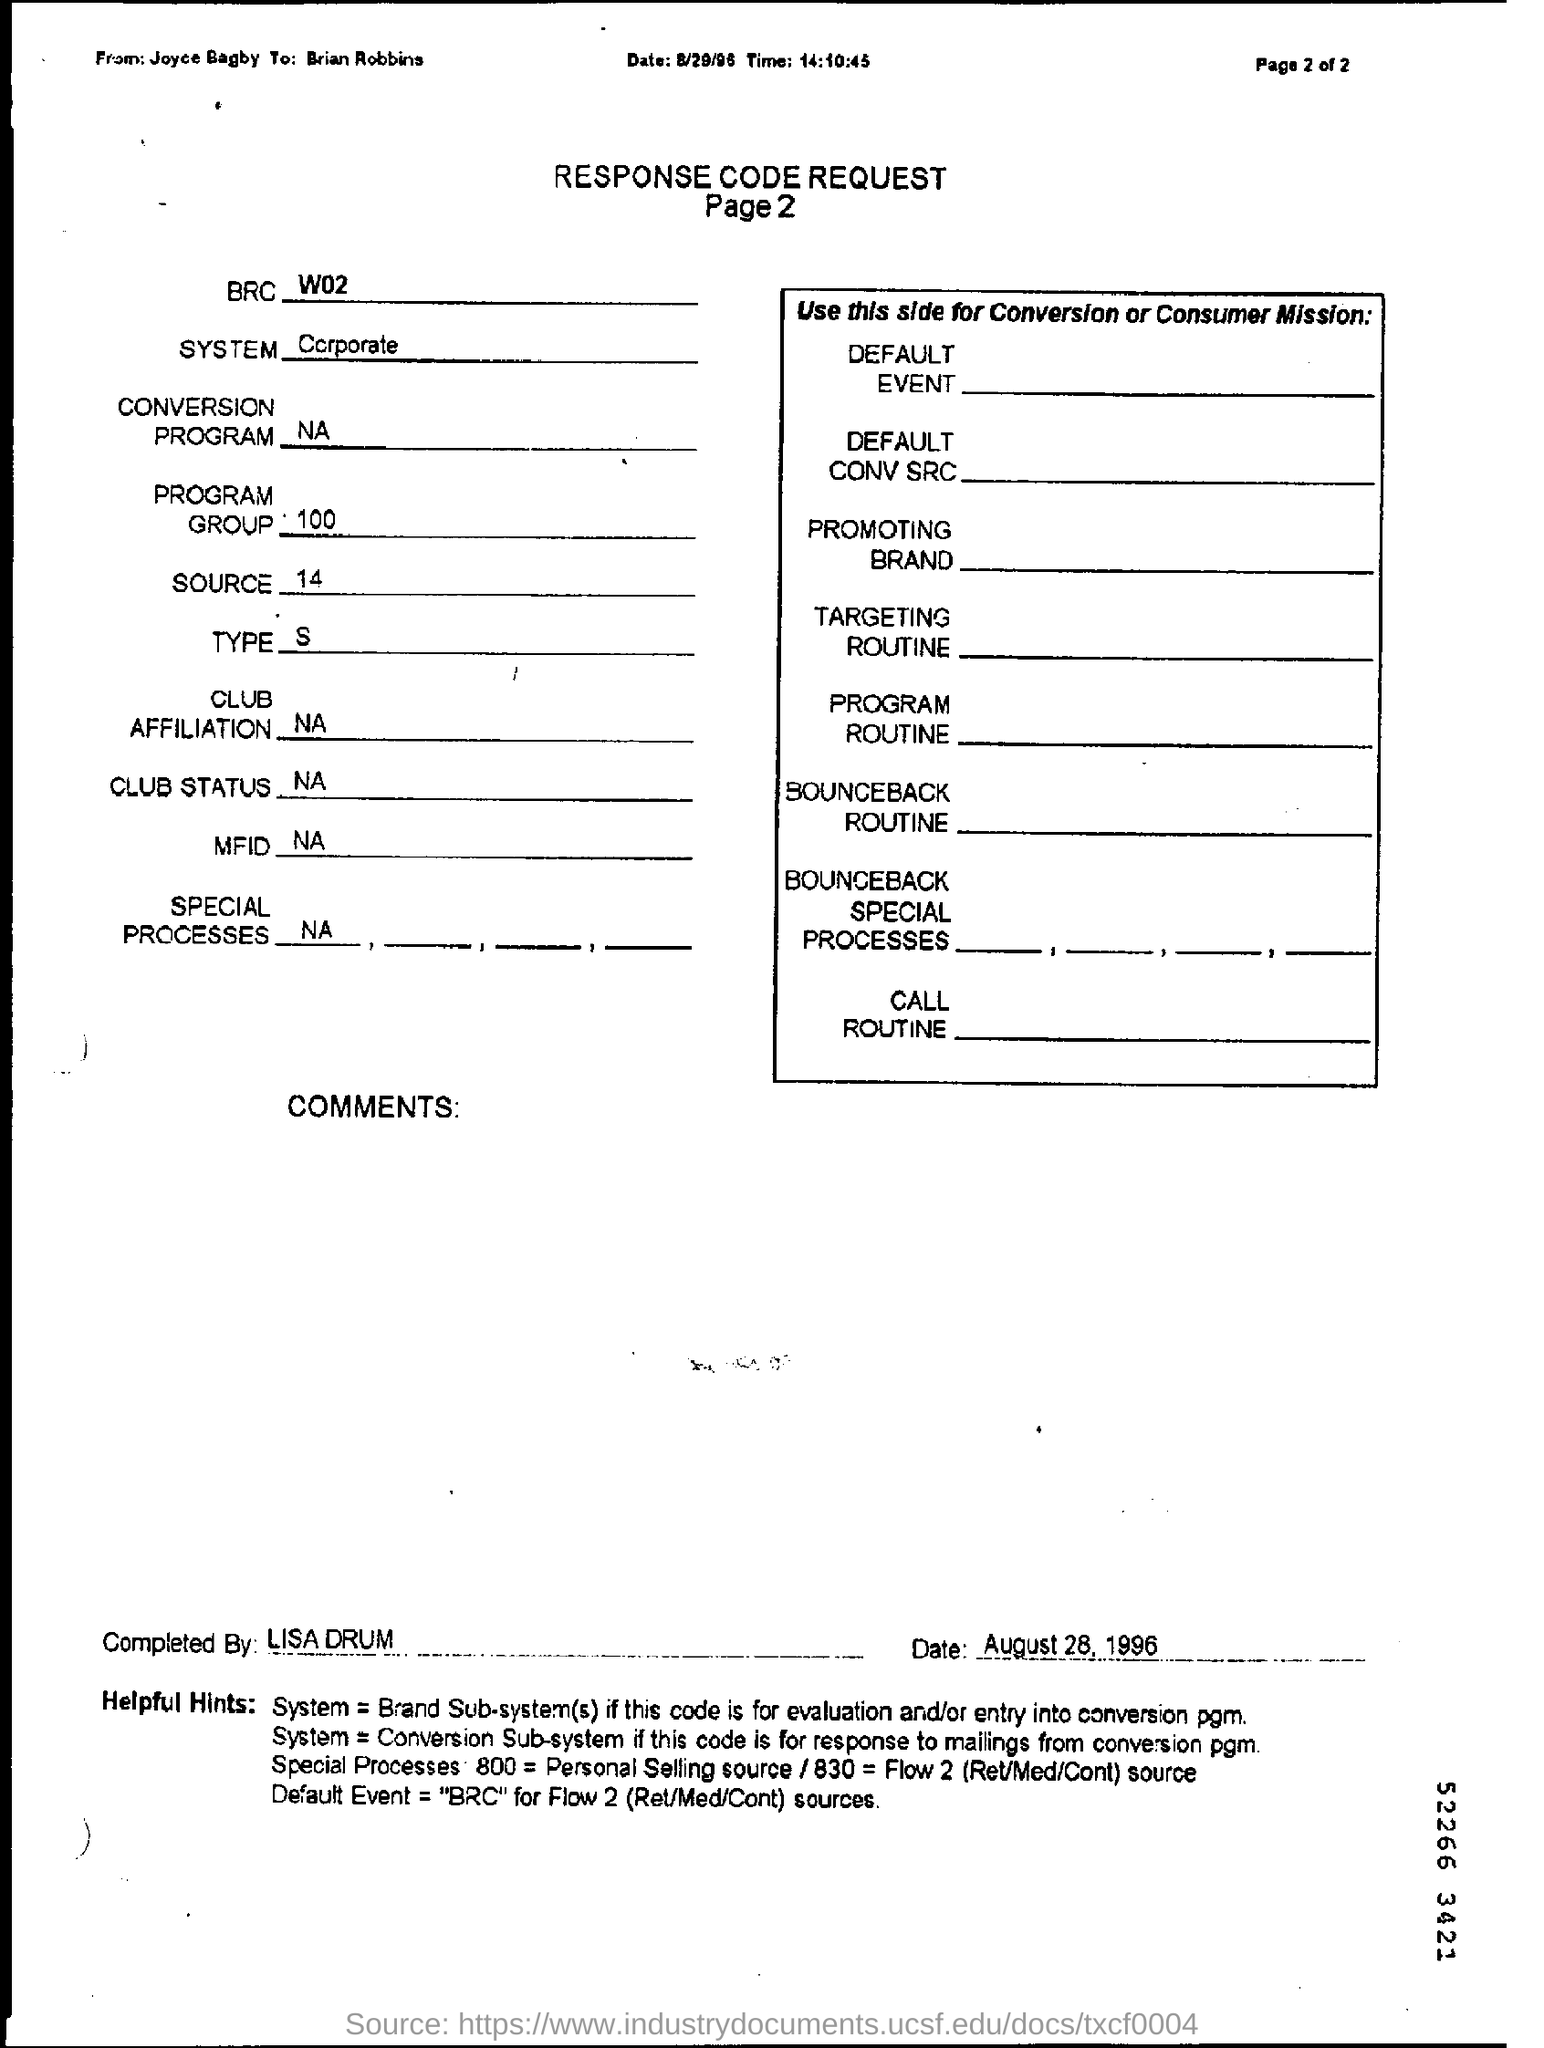who completed this response code request ? The response code request document appears to have been completed by an individual named Lisa Drum on August 28, 1996, as indicated by the handwritten signature and date on the bottom of the form. 